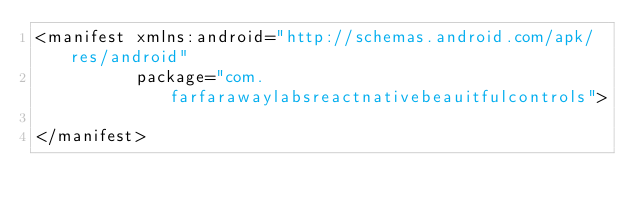Convert code to text. <code><loc_0><loc_0><loc_500><loc_500><_XML_><manifest xmlns:android="http://schemas.android.com/apk/res/android"
          package="com.farfarawaylabsreactnativebeauitfulcontrols">

</manifest>
</code> 